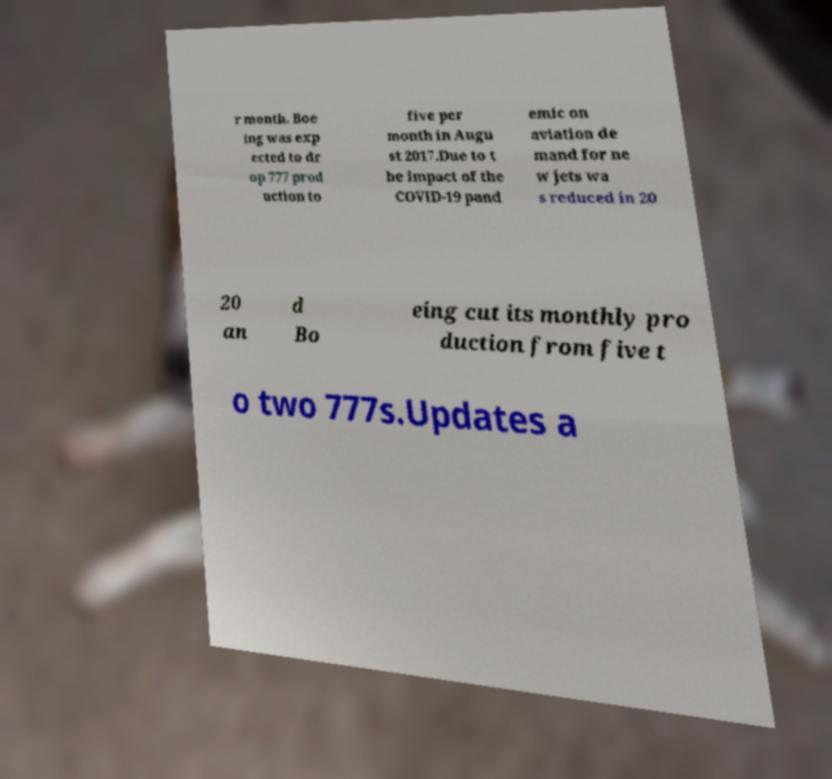Can you read and provide the text displayed in the image?This photo seems to have some interesting text. Can you extract and type it out for me? r month. Boe ing was exp ected to dr op 777 prod uction to five per month in Augu st 2017.Due to t he impact of the COVID-19 pand emic on aviation de mand for ne w jets wa s reduced in 20 20 an d Bo eing cut its monthly pro duction from five t o two 777s.Updates a 